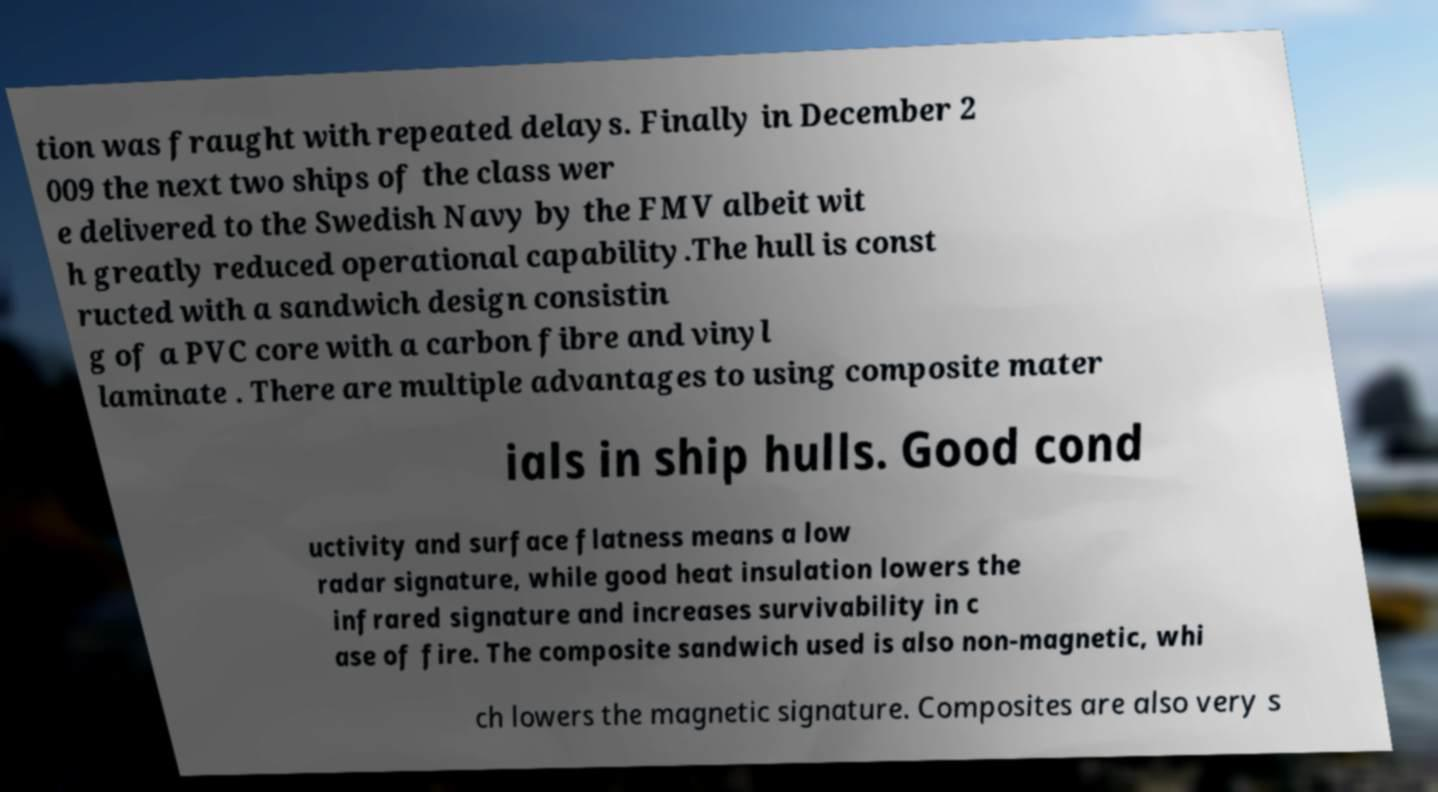What messages or text are displayed in this image? I need them in a readable, typed format. tion was fraught with repeated delays. Finally in December 2 009 the next two ships of the class wer e delivered to the Swedish Navy by the FMV albeit wit h greatly reduced operational capability.The hull is const ructed with a sandwich design consistin g of a PVC core with a carbon fibre and vinyl laminate . There are multiple advantages to using composite mater ials in ship hulls. Good cond uctivity and surface flatness means a low radar signature, while good heat insulation lowers the infrared signature and increases survivability in c ase of fire. The composite sandwich used is also non-magnetic, whi ch lowers the magnetic signature. Composites are also very s 